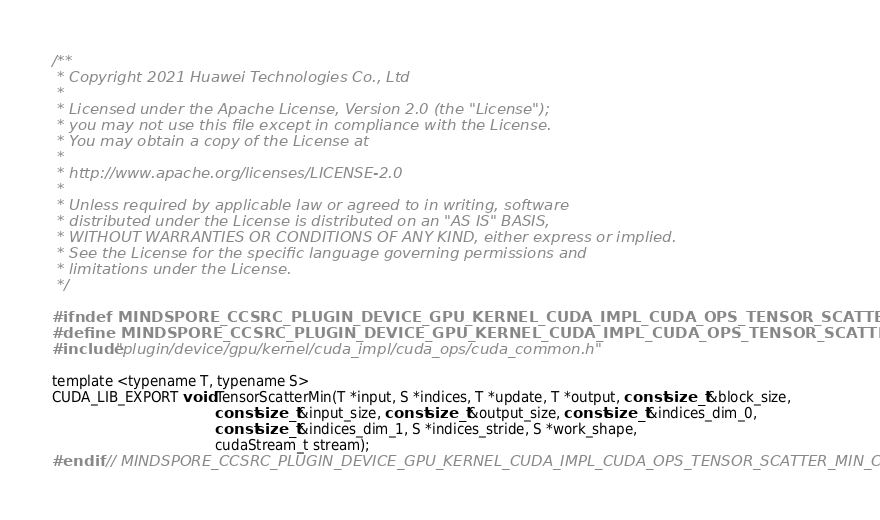<code> <loc_0><loc_0><loc_500><loc_500><_Cuda_>/**
 * Copyright 2021 Huawei Technologies Co., Ltd
 *
 * Licensed under the Apache License, Version 2.0 (the "License");
 * you may not use this file except in compliance with the License.
 * You may obtain a copy of the License at
 *
 * http://www.apache.org/licenses/LICENSE-2.0
 *
 * Unless required by applicable law or agreed to in writing, software
 * distributed under the License is distributed on an "AS IS" BASIS,
 * WITHOUT WARRANTIES OR CONDITIONS OF ANY KIND, either express or implied.
 * See the License for the specific language governing permissions and
 * limitations under the License.
 */

#ifndef MINDSPORE_CCSRC_PLUGIN_DEVICE_GPU_KERNEL_CUDA_IMPL_CUDA_OPS_TENSOR_SCATTER_MIN_CUH_
#define MINDSPORE_CCSRC_PLUGIN_DEVICE_GPU_KERNEL_CUDA_IMPL_CUDA_OPS_TENSOR_SCATTER_MIN_CUH_
#include "plugin/device/gpu/kernel/cuda_impl/cuda_ops/cuda_common.h"

template <typename T, typename S>
CUDA_LIB_EXPORT void TensorScatterMin(T *input, S *indices, T *update, T *output, const size_t &block_size,
                                      const size_t &input_size, const size_t &output_size, const size_t &indices_dim_0,
                                      const size_t &indices_dim_1, S *indices_stride, S *work_shape,
                                      cudaStream_t stream);
#endif  // MINDSPORE_CCSRC_PLUGIN_DEVICE_GPU_KERNEL_CUDA_IMPL_CUDA_OPS_TENSOR_SCATTER_MIN_CUH_
</code> 